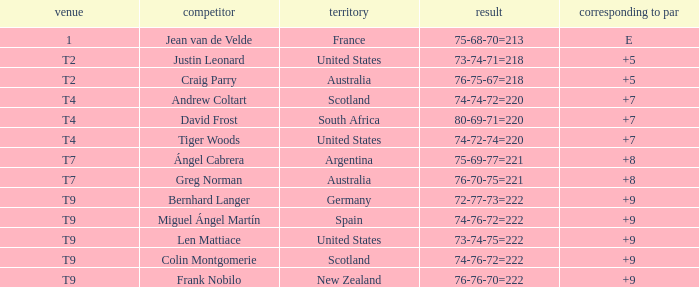Which player from Scotland has a To Par score of +7? Andrew Coltart. 